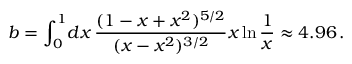<formula> <loc_0><loc_0><loc_500><loc_500>b = \int _ { 0 } ^ { 1 } \, d x \, { \frac { ( 1 - x + x ^ { 2 } ) ^ { 5 / 2 } } { ( x - x ^ { 2 } ) ^ { 3 / 2 } } } x \ln { \frac { 1 } { x } } \approx 4 . 9 6 \, .</formula> 